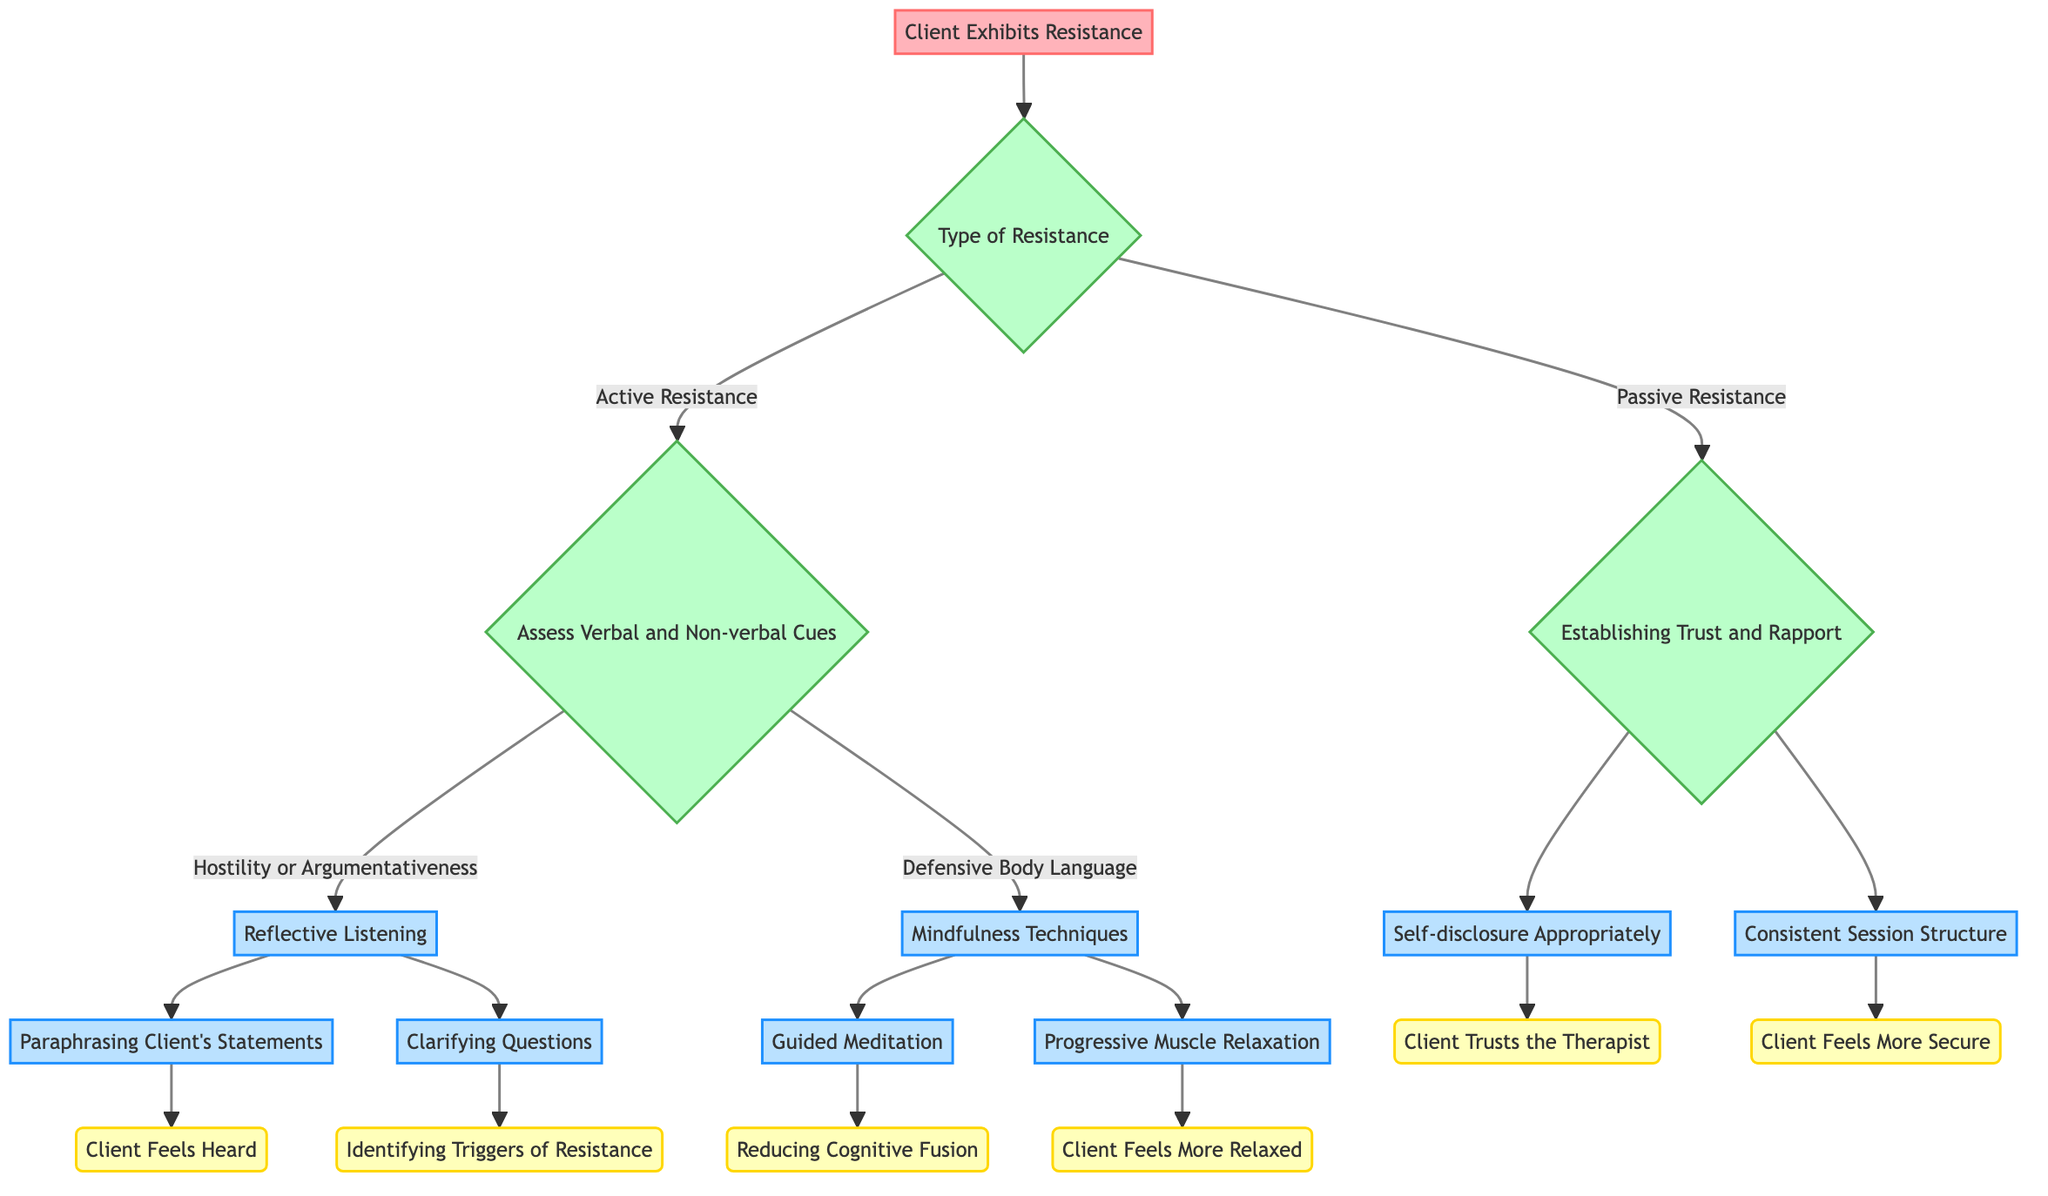What is the root node of the Decision Tree? The root node is the starting point of the diagram, which is labeled as "Client Exhibits Resistance". This node doesn't have any incoming edges and serves as the entry to the decision-making process.
Answer: Client Exhibits Resistance How many main conditions are there under the "Type of Resistance"? There are two branches under the "Type of Resistance": "Active Resistance" and "Passive Resistance". Counting these branches gives the total number of main conditions.
Answer: 2 What strategy follows "Mindfulness Techniques"? The strategy that follows "Mindfulness Techniques" can be determined by looking at the branches leading from that node. It branches to "Guided Meditation" and "Progressive Muscle Relaxation". Therefore, both strategies are valid follow-ups.
Answer: Guided Meditation, Progressive Muscle Relaxation What is the result of "Paraphrasing Client's Statements"? To find this, we look at the flow from "Paraphrasing Client's Statements" which leads to "Empathy and Validation", and then results in "Client Feels Heard". Thus, the outcome associated with this strategy is clear.
Answer: Client Feels Heard Which condition leads to "Reducing Fear of Unknown"? By tracing the paths, "Building Predictability" leads to the result "Client Feels More Secure", which then leads to "Reducing Fear of Unknown". We can confirm this by identifying the preceding conditions.
Answer: Building Predictability What consequence follows if a client trusts the therapist? Following the flow from "Creating a Safe Space" to its consequence, we see that when "Client Trusts the Therapist", the result is "Increased Willingness to Engage". This confirms the positive outcome of establishing trust.
Answer: Increased Willingness to Engage Which type of resistance directs us to "Assess Verbal and Non-verbal Cues"? Referring back to the initial decision point under the root node, “Active Resistance” directs you to "Assess Verbal and Non-verbal Cues". This indicates the specific conditions associated with active resistance.
Answer: Active Resistance What leads to "Facilitating Open Communication"? The path to "Facilitating Open Communication" originates from "Reducing Physical Tension", which itself is a next step after implementing "Progressive Muscle Relaxation". Following the chains of reasoning shows how physical relaxation supports communication.
Answer: Reducing Physical Tension Which strategy would you use if a client shows defensive body language? The diagram shows that defensive body language leads to "Mindfulness Techniques". This context provides clarity on the appropriate intervention when encountering this type of resistance.
Answer: Mindfulness Techniques 